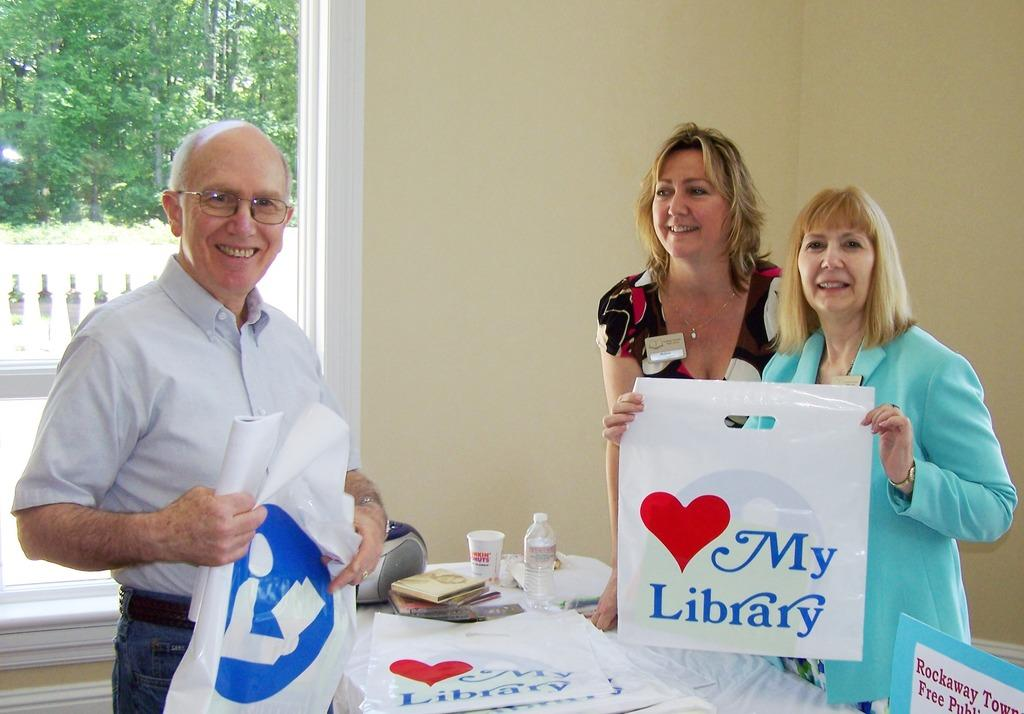<image>
Provide a brief description of the given image. an I love my library bag someone is holding with others 